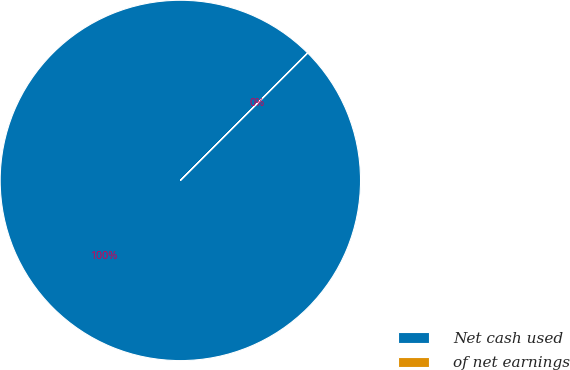Convert chart. <chart><loc_0><loc_0><loc_500><loc_500><pie_chart><fcel>Net cash used<fcel>of net earnings<nl><fcel>99.98%<fcel>0.02%<nl></chart> 